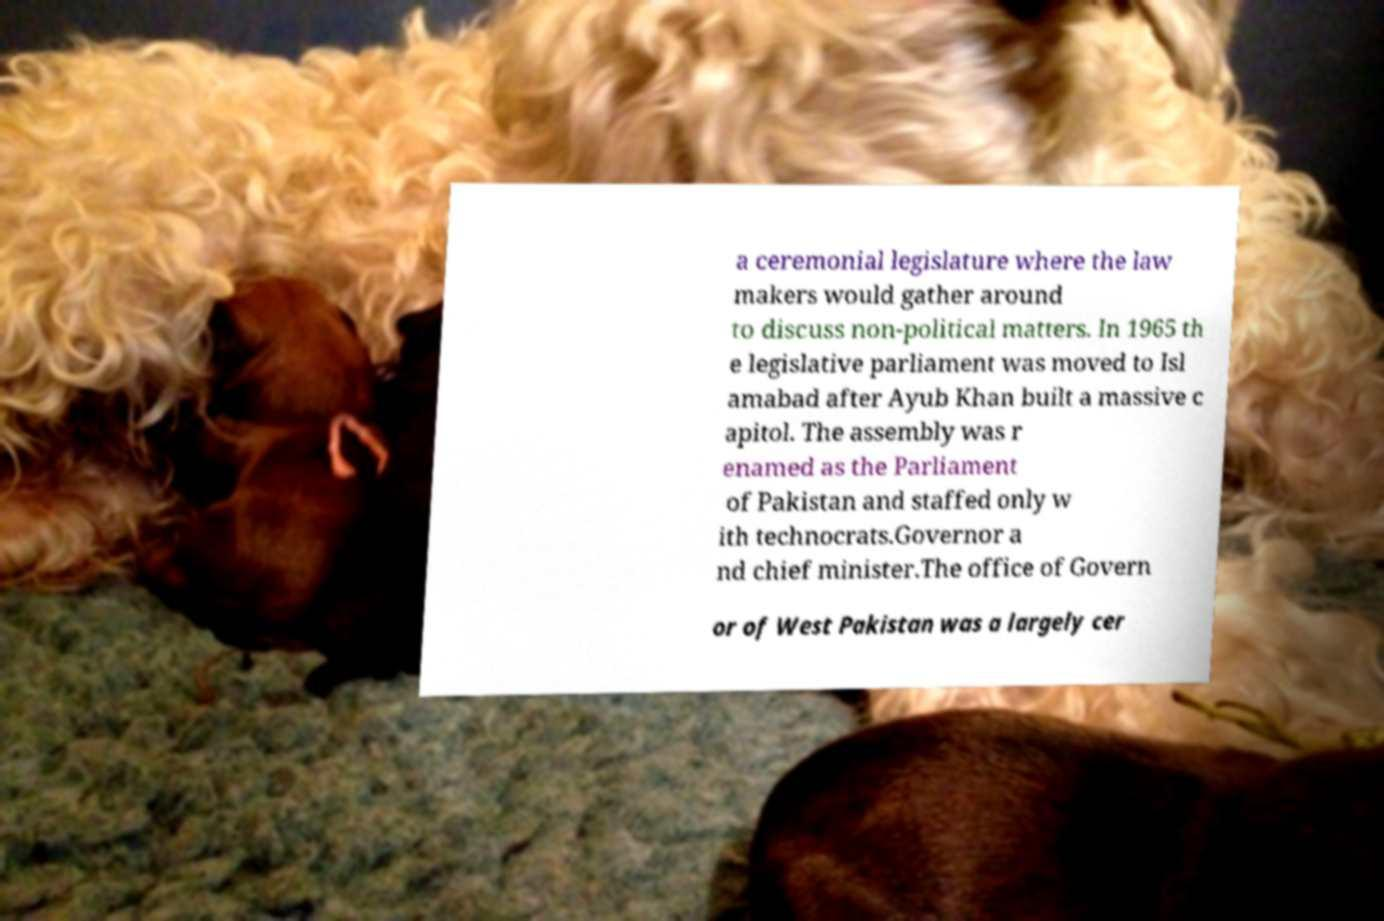I need the written content from this picture converted into text. Can you do that? a ceremonial legislature where the law makers would gather around to discuss non-political matters. In 1965 th e legislative parliament was moved to Isl amabad after Ayub Khan built a massive c apitol. The assembly was r enamed as the Parliament of Pakistan and staffed only w ith technocrats.Governor a nd chief minister.The office of Govern or of West Pakistan was a largely cer 